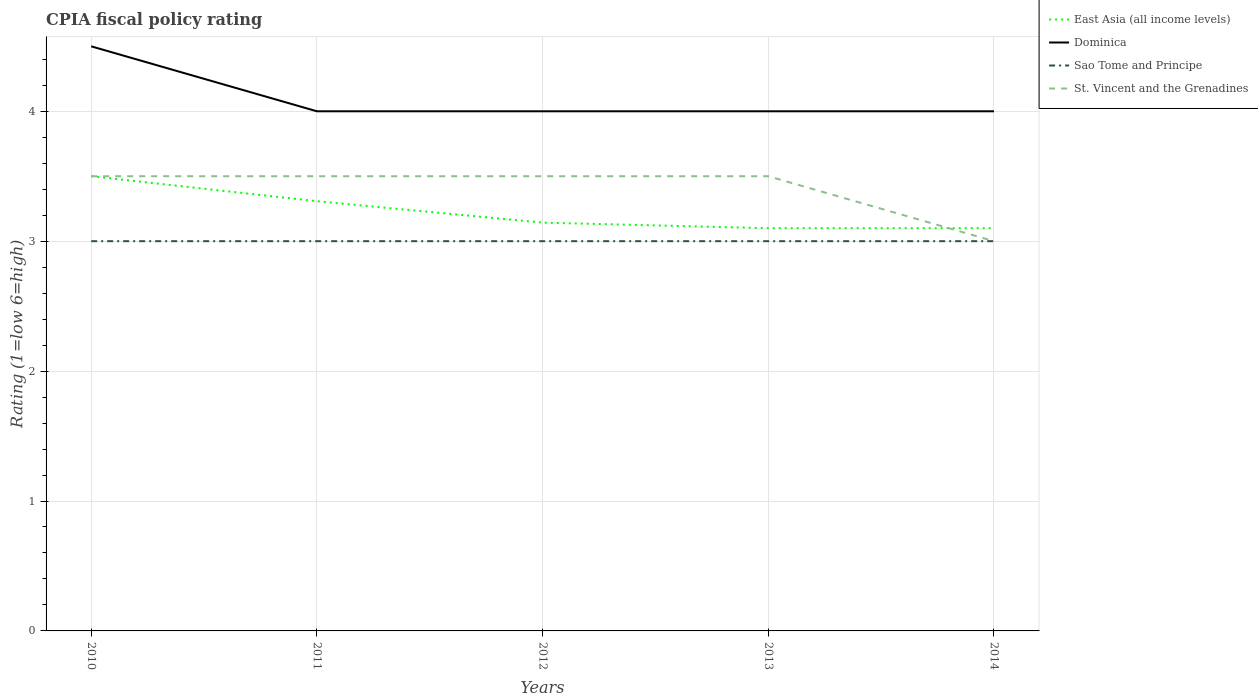How many different coloured lines are there?
Make the answer very short. 4. Across all years, what is the maximum CPIA rating in Sao Tome and Principe?
Make the answer very short. 3. In which year was the CPIA rating in St. Vincent and the Grenadines maximum?
Keep it short and to the point. 2014. What is the total CPIA rating in East Asia (all income levels) in the graph?
Your answer should be very brief. 0.21. What is the difference between the highest and the lowest CPIA rating in Dominica?
Offer a terse response. 1. Is the CPIA rating in Dominica strictly greater than the CPIA rating in Sao Tome and Principe over the years?
Provide a succinct answer. No. How many years are there in the graph?
Your answer should be compact. 5. What is the difference between two consecutive major ticks on the Y-axis?
Make the answer very short. 1. Where does the legend appear in the graph?
Give a very brief answer. Top right. How many legend labels are there?
Provide a succinct answer. 4. What is the title of the graph?
Ensure brevity in your answer.  CPIA fiscal policy rating. What is the Rating (1=low 6=high) of Sao Tome and Principe in 2010?
Ensure brevity in your answer.  3. What is the Rating (1=low 6=high) in St. Vincent and the Grenadines in 2010?
Give a very brief answer. 3.5. What is the Rating (1=low 6=high) in East Asia (all income levels) in 2011?
Ensure brevity in your answer.  3.31. What is the Rating (1=low 6=high) of Dominica in 2011?
Offer a very short reply. 4. What is the Rating (1=low 6=high) in Sao Tome and Principe in 2011?
Offer a very short reply. 3. What is the Rating (1=low 6=high) of St. Vincent and the Grenadines in 2011?
Your answer should be very brief. 3.5. What is the Rating (1=low 6=high) of East Asia (all income levels) in 2012?
Give a very brief answer. 3.14. What is the Rating (1=low 6=high) of St. Vincent and the Grenadines in 2012?
Keep it short and to the point. 3.5. What is the Rating (1=low 6=high) in East Asia (all income levels) in 2013?
Offer a terse response. 3.1. Across all years, what is the maximum Rating (1=low 6=high) in East Asia (all income levels)?
Make the answer very short. 3.5. Across all years, what is the maximum Rating (1=low 6=high) of St. Vincent and the Grenadines?
Your response must be concise. 3.5. Across all years, what is the minimum Rating (1=low 6=high) of East Asia (all income levels)?
Offer a terse response. 3.1. Across all years, what is the minimum Rating (1=low 6=high) in St. Vincent and the Grenadines?
Offer a terse response. 3. What is the total Rating (1=low 6=high) of East Asia (all income levels) in the graph?
Ensure brevity in your answer.  16.15. What is the total Rating (1=low 6=high) of Dominica in the graph?
Offer a very short reply. 20.5. What is the total Rating (1=low 6=high) of Sao Tome and Principe in the graph?
Provide a short and direct response. 15. What is the difference between the Rating (1=low 6=high) of East Asia (all income levels) in 2010 and that in 2011?
Provide a succinct answer. 0.19. What is the difference between the Rating (1=low 6=high) in Sao Tome and Principe in 2010 and that in 2011?
Offer a very short reply. 0. What is the difference between the Rating (1=low 6=high) in East Asia (all income levels) in 2010 and that in 2012?
Your answer should be compact. 0.36. What is the difference between the Rating (1=low 6=high) of Dominica in 2010 and that in 2012?
Your response must be concise. 0.5. What is the difference between the Rating (1=low 6=high) in Sao Tome and Principe in 2010 and that in 2012?
Offer a terse response. 0. What is the difference between the Rating (1=low 6=high) of East Asia (all income levels) in 2010 and that in 2013?
Keep it short and to the point. 0.4. What is the difference between the Rating (1=low 6=high) of Dominica in 2010 and that in 2013?
Ensure brevity in your answer.  0.5. What is the difference between the Rating (1=low 6=high) in St. Vincent and the Grenadines in 2010 and that in 2013?
Give a very brief answer. 0. What is the difference between the Rating (1=low 6=high) of Dominica in 2010 and that in 2014?
Keep it short and to the point. 0.5. What is the difference between the Rating (1=low 6=high) in Sao Tome and Principe in 2010 and that in 2014?
Your answer should be very brief. 0. What is the difference between the Rating (1=low 6=high) in St. Vincent and the Grenadines in 2010 and that in 2014?
Your answer should be very brief. 0.5. What is the difference between the Rating (1=low 6=high) in East Asia (all income levels) in 2011 and that in 2012?
Make the answer very short. 0.16. What is the difference between the Rating (1=low 6=high) in East Asia (all income levels) in 2011 and that in 2013?
Your answer should be very brief. 0.21. What is the difference between the Rating (1=low 6=high) of Dominica in 2011 and that in 2013?
Your response must be concise. 0. What is the difference between the Rating (1=low 6=high) of Sao Tome and Principe in 2011 and that in 2013?
Offer a terse response. 0. What is the difference between the Rating (1=low 6=high) of East Asia (all income levels) in 2011 and that in 2014?
Provide a short and direct response. 0.21. What is the difference between the Rating (1=low 6=high) in Dominica in 2011 and that in 2014?
Offer a terse response. 0. What is the difference between the Rating (1=low 6=high) of East Asia (all income levels) in 2012 and that in 2013?
Provide a short and direct response. 0.04. What is the difference between the Rating (1=low 6=high) in East Asia (all income levels) in 2012 and that in 2014?
Keep it short and to the point. 0.04. What is the difference between the Rating (1=low 6=high) in Dominica in 2012 and that in 2014?
Your answer should be compact. 0. What is the difference between the Rating (1=low 6=high) of Sao Tome and Principe in 2012 and that in 2014?
Offer a terse response. 0. What is the difference between the Rating (1=low 6=high) of Sao Tome and Principe in 2013 and that in 2014?
Your response must be concise. 0. What is the difference between the Rating (1=low 6=high) of East Asia (all income levels) in 2010 and the Rating (1=low 6=high) of Sao Tome and Principe in 2011?
Provide a succinct answer. 0.5. What is the difference between the Rating (1=low 6=high) of Dominica in 2010 and the Rating (1=low 6=high) of Sao Tome and Principe in 2011?
Your answer should be very brief. 1.5. What is the difference between the Rating (1=low 6=high) in East Asia (all income levels) in 2010 and the Rating (1=low 6=high) in Dominica in 2012?
Keep it short and to the point. -0.5. What is the difference between the Rating (1=low 6=high) of East Asia (all income levels) in 2010 and the Rating (1=low 6=high) of St. Vincent and the Grenadines in 2012?
Your response must be concise. 0. What is the difference between the Rating (1=low 6=high) of Sao Tome and Principe in 2010 and the Rating (1=low 6=high) of St. Vincent and the Grenadines in 2012?
Offer a very short reply. -0.5. What is the difference between the Rating (1=low 6=high) of East Asia (all income levels) in 2010 and the Rating (1=low 6=high) of Dominica in 2013?
Your answer should be compact. -0.5. What is the difference between the Rating (1=low 6=high) in East Asia (all income levels) in 2010 and the Rating (1=low 6=high) in Sao Tome and Principe in 2013?
Keep it short and to the point. 0.5. What is the difference between the Rating (1=low 6=high) of East Asia (all income levels) in 2010 and the Rating (1=low 6=high) of St. Vincent and the Grenadines in 2013?
Your answer should be compact. 0. What is the difference between the Rating (1=low 6=high) in Sao Tome and Principe in 2010 and the Rating (1=low 6=high) in St. Vincent and the Grenadines in 2013?
Offer a terse response. -0.5. What is the difference between the Rating (1=low 6=high) of East Asia (all income levels) in 2010 and the Rating (1=low 6=high) of Sao Tome and Principe in 2014?
Your answer should be compact. 0.5. What is the difference between the Rating (1=low 6=high) in East Asia (all income levels) in 2010 and the Rating (1=low 6=high) in St. Vincent and the Grenadines in 2014?
Give a very brief answer. 0.5. What is the difference between the Rating (1=low 6=high) in Dominica in 2010 and the Rating (1=low 6=high) in St. Vincent and the Grenadines in 2014?
Offer a terse response. 1.5. What is the difference between the Rating (1=low 6=high) in Sao Tome and Principe in 2010 and the Rating (1=low 6=high) in St. Vincent and the Grenadines in 2014?
Provide a succinct answer. 0. What is the difference between the Rating (1=low 6=high) of East Asia (all income levels) in 2011 and the Rating (1=low 6=high) of Dominica in 2012?
Ensure brevity in your answer.  -0.69. What is the difference between the Rating (1=low 6=high) of East Asia (all income levels) in 2011 and the Rating (1=low 6=high) of Sao Tome and Principe in 2012?
Your answer should be compact. 0.31. What is the difference between the Rating (1=low 6=high) of East Asia (all income levels) in 2011 and the Rating (1=low 6=high) of St. Vincent and the Grenadines in 2012?
Make the answer very short. -0.19. What is the difference between the Rating (1=low 6=high) in Dominica in 2011 and the Rating (1=low 6=high) in St. Vincent and the Grenadines in 2012?
Offer a very short reply. 0.5. What is the difference between the Rating (1=low 6=high) in East Asia (all income levels) in 2011 and the Rating (1=low 6=high) in Dominica in 2013?
Ensure brevity in your answer.  -0.69. What is the difference between the Rating (1=low 6=high) in East Asia (all income levels) in 2011 and the Rating (1=low 6=high) in Sao Tome and Principe in 2013?
Provide a short and direct response. 0.31. What is the difference between the Rating (1=low 6=high) of East Asia (all income levels) in 2011 and the Rating (1=low 6=high) of St. Vincent and the Grenadines in 2013?
Offer a very short reply. -0.19. What is the difference between the Rating (1=low 6=high) in Dominica in 2011 and the Rating (1=low 6=high) in St. Vincent and the Grenadines in 2013?
Offer a very short reply. 0.5. What is the difference between the Rating (1=low 6=high) in East Asia (all income levels) in 2011 and the Rating (1=low 6=high) in Dominica in 2014?
Give a very brief answer. -0.69. What is the difference between the Rating (1=low 6=high) of East Asia (all income levels) in 2011 and the Rating (1=low 6=high) of Sao Tome and Principe in 2014?
Your response must be concise. 0.31. What is the difference between the Rating (1=low 6=high) in East Asia (all income levels) in 2011 and the Rating (1=low 6=high) in St. Vincent and the Grenadines in 2014?
Offer a terse response. 0.31. What is the difference between the Rating (1=low 6=high) in Dominica in 2011 and the Rating (1=low 6=high) in Sao Tome and Principe in 2014?
Offer a terse response. 1. What is the difference between the Rating (1=low 6=high) of Sao Tome and Principe in 2011 and the Rating (1=low 6=high) of St. Vincent and the Grenadines in 2014?
Provide a succinct answer. 0. What is the difference between the Rating (1=low 6=high) in East Asia (all income levels) in 2012 and the Rating (1=low 6=high) in Dominica in 2013?
Keep it short and to the point. -0.86. What is the difference between the Rating (1=low 6=high) of East Asia (all income levels) in 2012 and the Rating (1=low 6=high) of Sao Tome and Principe in 2013?
Ensure brevity in your answer.  0.14. What is the difference between the Rating (1=low 6=high) of East Asia (all income levels) in 2012 and the Rating (1=low 6=high) of St. Vincent and the Grenadines in 2013?
Give a very brief answer. -0.36. What is the difference between the Rating (1=low 6=high) of East Asia (all income levels) in 2012 and the Rating (1=low 6=high) of Dominica in 2014?
Your answer should be compact. -0.86. What is the difference between the Rating (1=low 6=high) in East Asia (all income levels) in 2012 and the Rating (1=low 6=high) in Sao Tome and Principe in 2014?
Offer a very short reply. 0.14. What is the difference between the Rating (1=low 6=high) of East Asia (all income levels) in 2012 and the Rating (1=low 6=high) of St. Vincent and the Grenadines in 2014?
Offer a terse response. 0.14. What is the difference between the Rating (1=low 6=high) of Sao Tome and Principe in 2012 and the Rating (1=low 6=high) of St. Vincent and the Grenadines in 2014?
Make the answer very short. 0. What is the average Rating (1=low 6=high) of East Asia (all income levels) per year?
Ensure brevity in your answer.  3.23. What is the average Rating (1=low 6=high) in Dominica per year?
Your answer should be compact. 4.1. In the year 2010, what is the difference between the Rating (1=low 6=high) of Dominica and Rating (1=low 6=high) of Sao Tome and Principe?
Make the answer very short. 1.5. In the year 2010, what is the difference between the Rating (1=low 6=high) of Sao Tome and Principe and Rating (1=low 6=high) of St. Vincent and the Grenadines?
Keep it short and to the point. -0.5. In the year 2011, what is the difference between the Rating (1=low 6=high) of East Asia (all income levels) and Rating (1=low 6=high) of Dominica?
Provide a short and direct response. -0.69. In the year 2011, what is the difference between the Rating (1=low 6=high) of East Asia (all income levels) and Rating (1=low 6=high) of Sao Tome and Principe?
Make the answer very short. 0.31. In the year 2011, what is the difference between the Rating (1=low 6=high) of East Asia (all income levels) and Rating (1=low 6=high) of St. Vincent and the Grenadines?
Offer a terse response. -0.19. In the year 2011, what is the difference between the Rating (1=low 6=high) of Dominica and Rating (1=low 6=high) of Sao Tome and Principe?
Your answer should be very brief. 1. In the year 2012, what is the difference between the Rating (1=low 6=high) in East Asia (all income levels) and Rating (1=low 6=high) in Dominica?
Give a very brief answer. -0.86. In the year 2012, what is the difference between the Rating (1=low 6=high) in East Asia (all income levels) and Rating (1=low 6=high) in Sao Tome and Principe?
Make the answer very short. 0.14. In the year 2012, what is the difference between the Rating (1=low 6=high) in East Asia (all income levels) and Rating (1=low 6=high) in St. Vincent and the Grenadines?
Offer a very short reply. -0.36. In the year 2012, what is the difference between the Rating (1=low 6=high) in Dominica and Rating (1=low 6=high) in Sao Tome and Principe?
Ensure brevity in your answer.  1. In the year 2012, what is the difference between the Rating (1=low 6=high) of Dominica and Rating (1=low 6=high) of St. Vincent and the Grenadines?
Offer a terse response. 0.5. In the year 2013, what is the difference between the Rating (1=low 6=high) in East Asia (all income levels) and Rating (1=low 6=high) in Dominica?
Give a very brief answer. -0.9. In the year 2014, what is the difference between the Rating (1=low 6=high) in East Asia (all income levels) and Rating (1=low 6=high) in Dominica?
Your answer should be compact. -0.9. In the year 2014, what is the difference between the Rating (1=low 6=high) in East Asia (all income levels) and Rating (1=low 6=high) in Sao Tome and Principe?
Make the answer very short. 0.1. In the year 2014, what is the difference between the Rating (1=low 6=high) of East Asia (all income levels) and Rating (1=low 6=high) of St. Vincent and the Grenadines?
Ensure brevity in your answer.  0.1. In the year 2014, what is the difference between the Rating (1=low 6=high) in Dominica and Rating (1=low 6=high) in Sao Tome and Principe?
Provide a succinct answer. 1. In the year 2014, what is the difference between the Rating (1=low 6=high) in Dominica and Rating (1=low 6=high) in St. Vincent and the Grenadines?
Keep it short and to the point. 1. What is the ratio of the Rating (1=low 6=high) of East Asia (all income levels) in 2010 to that in 2011?
Your response must be concise. 1.06. What is the ratio of the Rating (1=low 6=high) of Sao Tome and Principe in 2010 to that in 2011?
Your answer should be compact. 1. What is the ratio of the Rating (1=low 6=high) of East Asia (all income levels) in 2010 to that in 2012?
Give a very brief answer. 1.11. What is the ratio of the Rating (1=low 6=high) of Dominica in 2010 to that in 2012?
Give a very brief answer. 1.12. What is the ratio of the Rating (1=low 6=high) of Sao Tome and Principe in 2010 to that in 2012?
Give a very brief answer. 1. What is the ratio of the Rating (1=low 6=high) of St. Vincent and the Grenadines in 2010 to that in 2012?
Provide a short and direct response. 1. What is the ratio of the Rating (1=low 6=high) in East Asia (all income levels) in 2010 to that in 2013?
Your response must be concise. 1.13. What is the ratio of the Rating (1=low 6=high) in Dominica in 2010 to that in 2013?
Provide a succinct answer. 1.12. What is the ratio of the Rating (1=low 6=high) in Sao Tome and Principe in 2010 to that in 2013?
Ensure brevity in your answer.  1. What is the ratio of the Rating (1=low 6=high) in East Asia (all income levels) in 2010 to that in 2014?
Provide a succinct answer. 1.13. What is the ratio of the Rating (1=low 6=high) of Sao Tome and Principe in 2010 to that in 2014?
Provide a succinct answer. 1. What is the ratio of the Rating (1=low 6=high) of East Asia (all income levels) in 2011 to that in 2012?
Provide a succinct answer. 1.05. What is the ratio of the Rating (1=low 6=high) in St. Vincent and the Grenadines in 2011 to that in 2012?
Your answer should be very brief. 1. What is the ratio of the Rating (1=low 6=high) in East Asia (all income levels) in 2011 to that in 2013?
Give a very brief answer. 1.07. What is the ratio of the Rating (1=low 6=high) of St. Vincent and the Grenadines in 2011 to that in 2013?
Your answer should be very brief. 1. What is the ratio of the Rating (1=low 6=high) of East Asia (all income levels) in 2011 to that in 2014?
Your response must be concise. 1.07. What is the ratio of the Rating (1=low 6=high) in Dominica in 2011 to that in 2014?
Provide a succinct answer. 1. What is the ratio of the Rating (1=low 6=high) in St. Vincent and the Grenadines in 2011 to that in 2014?
Your answer should be very brief. 1.17. What is the ratio of the Rating (1=low 6=high) of East Asia (all income levels) in 2012 to that in 2013?
Keep it short and to the point. 1.01. What is the ratio of the Rating (1=low 6=high) of St. Vincent and the Grenadines in 2012 to that in 2013?
Your response must be concise. 1. What is the ratio of the Rating (1=low 6=high) of East Asia (all income levels) in 2012 to that in 2014?
Your response must be concise. 1.01. What is the ratio of the Rating (1=low 6=high) in East Asia (all income levels) in 2013 to that in 2014?
Make the answer very short. 1. What is the ratio of the Rating (1=low 6=high) of St. Vincent and the Grenadines in 2013 to that in 2014?
Your answer should be compact. 1.17. What is the difference between the highest and the second highest Rating (1=low 6=high) in East Asia (all income levels)?
Make the answer very short. 0.19. What is the difference between the highest and the second highest Rating (1=low 6=high) in Sao Tome and Principe?
Offer a very short reply. 0. What is the difference between the highest and the second highest Rating (1=low 6=high) of St. Vincent and the Grenadines?
Your answer should be compact. 0. What is the difference between the highest and the lowest Rating (1=low 6=high) of East Asia (all income levels)?
Give a very brief answer. 0.4. What is the difference between the highest and the lowest Rating (1=low 6=high) of Dominica?
Your answer should be compact. 0.5. What is the difference between the highest and the lowest Rating (1=low 6=high) in Sao Tome and Principe?
Ensure brevity in your answer.  0. What is the difference between the highest and the lowest Rating (1=low 6=high) in St. Vincent and the Grenadines?
Make the answer very short. 0.5. 